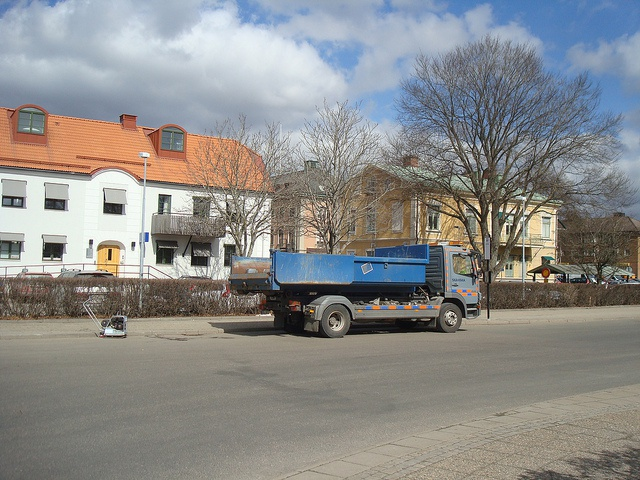Describe the objects in this image and their specific colors. I can see truck in gray, black, and darkgray tones, car in gray, darkgray, lightgray, and black tones, car in gray, darkgray, and lightgray tones, and car in gray, lightgray, darkgray, and darkgreen tones in this image. 